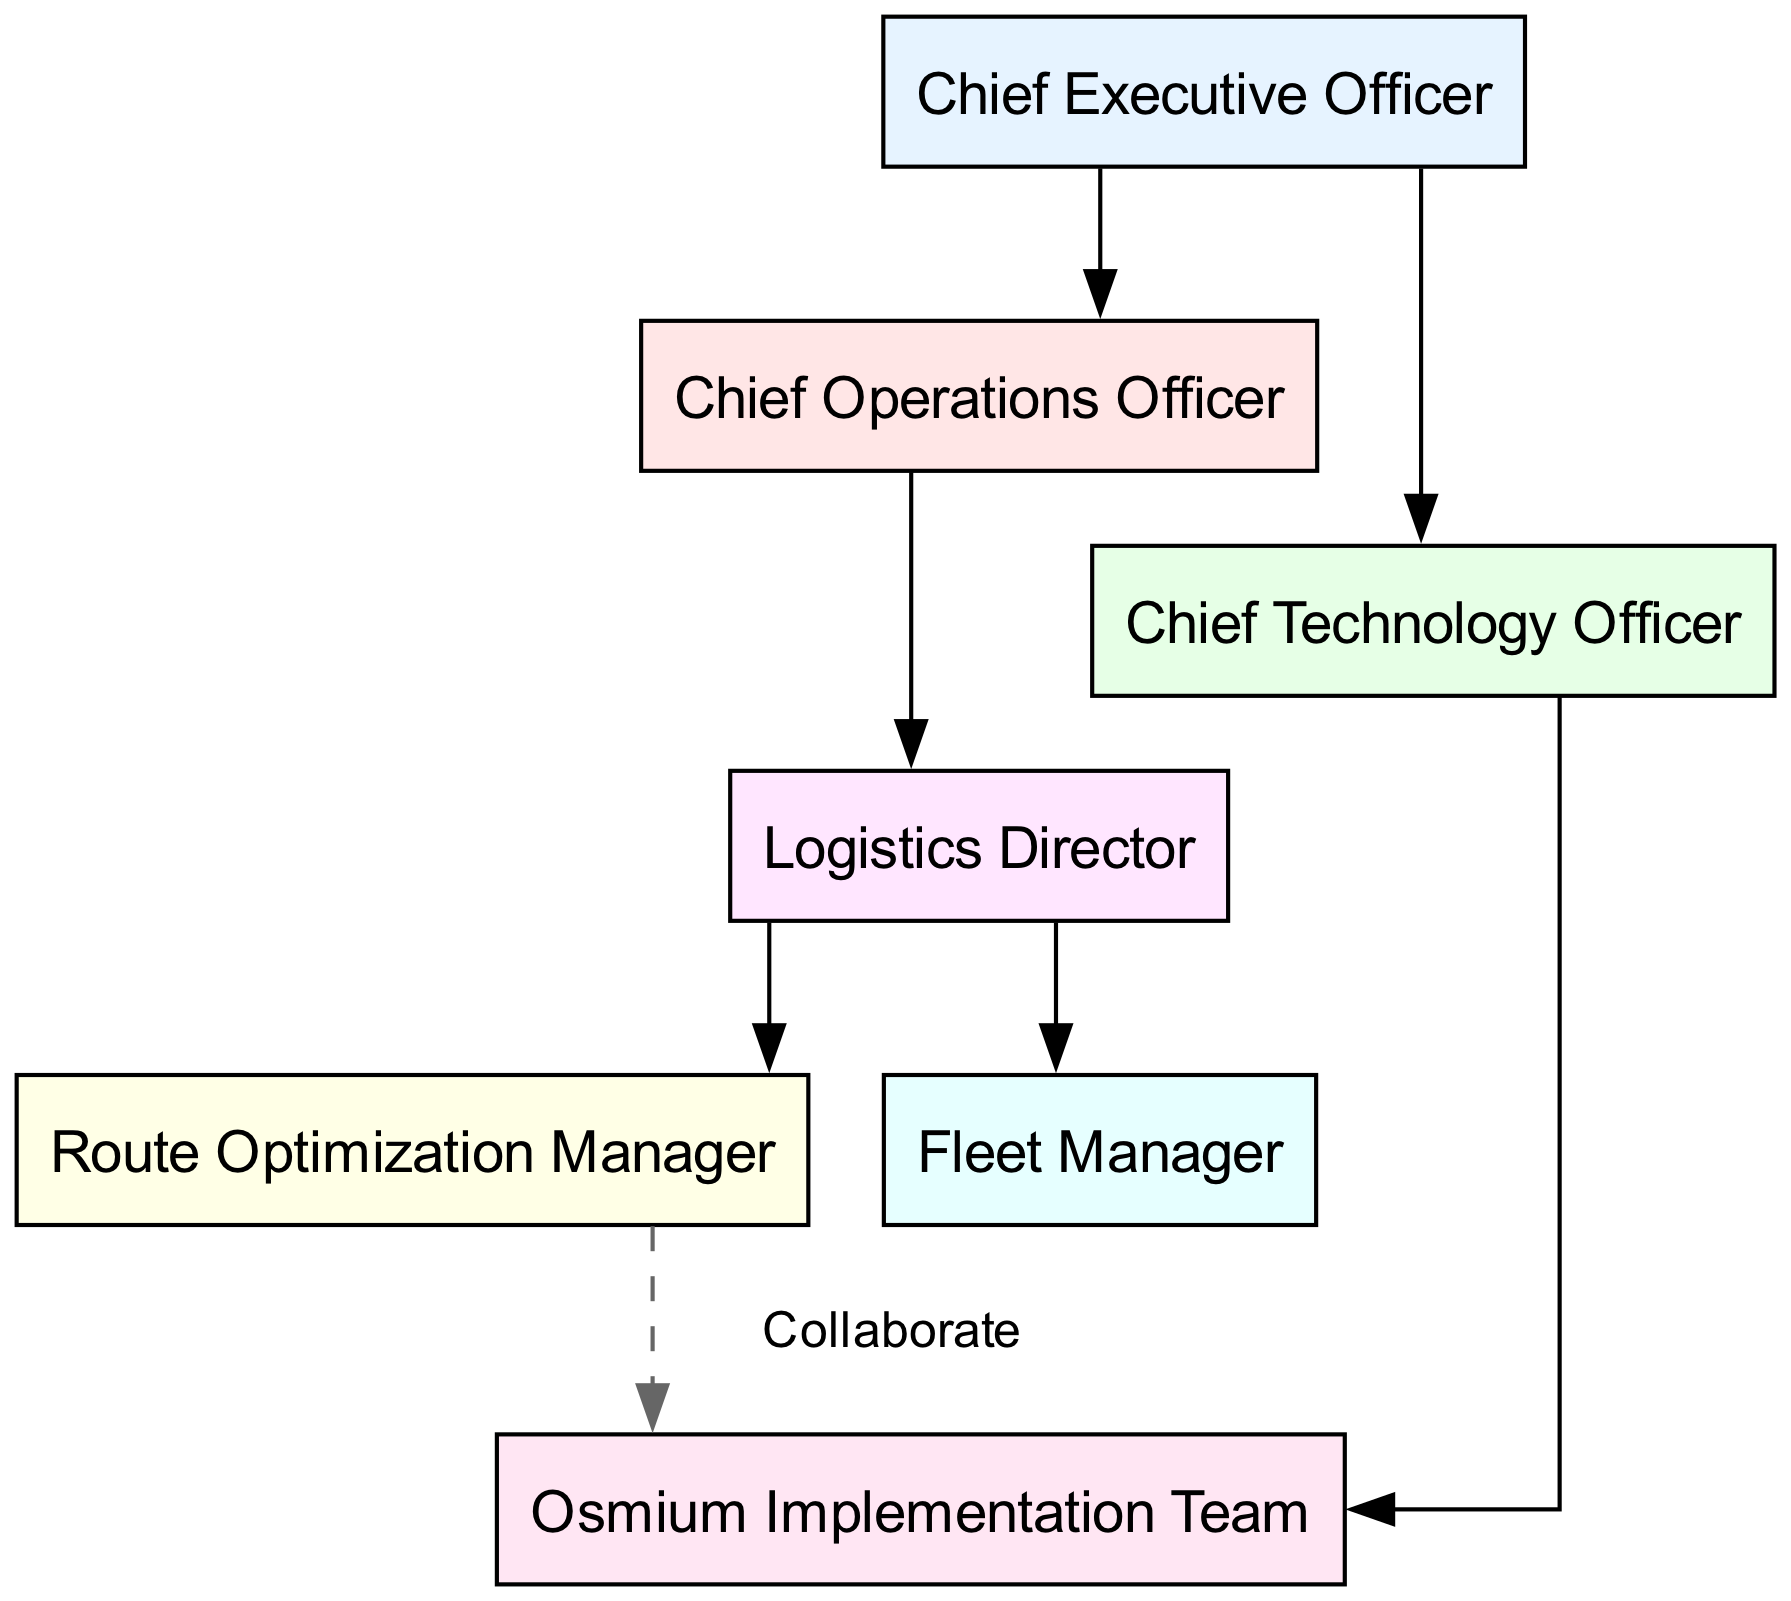What is the top position in the organizational chart? The topmost position in the chart is labeled "Chief Executive Officer," which is directly at the top and does not have any nodes above it.
Answer: Chief Executive Officer How many nodes are in the organizational chart? The chart includes a total of seven distinct nodes representing various positions within the company. Each node corresponds to a role in the hierarchy.
Answer: 7 Who does the Chief Operations Officer report to? The edge connecting the "COO" and "CEO" nodes indicates that the Chief Operations Officer directly reports to the Chief Executive Officer.
Answer: Chief Executive Officer What role directly oversees the Route Optimization Manager? The "Logistics Director" node has a directed edge pointing to the "Route Optimization Manager," indicating that the Route Optimization Manager falls under the supervision of the Logistics Director.
Answer: Logistics Director How many edges are there in the diagram? By counting the lines (edges) connecting the various roles in the diagram, there are a total of six edges shown that represent reporting relationships and collaboration.
Answer: 6 Which team collaborates with the Route Optimization Manager? The edge labeled "Collaborate" connects the "Route Optimization Manager" and the "Osmium Implementation Team," indicating that they work together.
Answer: Osmium Implementation Team What is the label of the node that is directly supervised by the Logistics Director and deals with fleet management? The "Fleet Manager" node is connected to the "Logistics Director" node, indicating that it is a role directly supervised by the Logistics Director focused on managing the fleet.
Answer: Fleet Manager What is the relationship between the CTO and the Osmium Implementation Team? The directed edge from the "CTO" to the "Osmium Implementation Team" shows that the Chief Technology Officer oversees or has direct responsibility for the team involved in Osmium.
Answer: Oversees Which role has a direct connection to both the Logistics Director and the Osmium Implementation Team? The "Route Optimization Manager" node is directly connected to the Logistics Director and also collaborates with the Osmium Implementation Team, indicating its dual connections.
Answer: Route Optimization Manager 